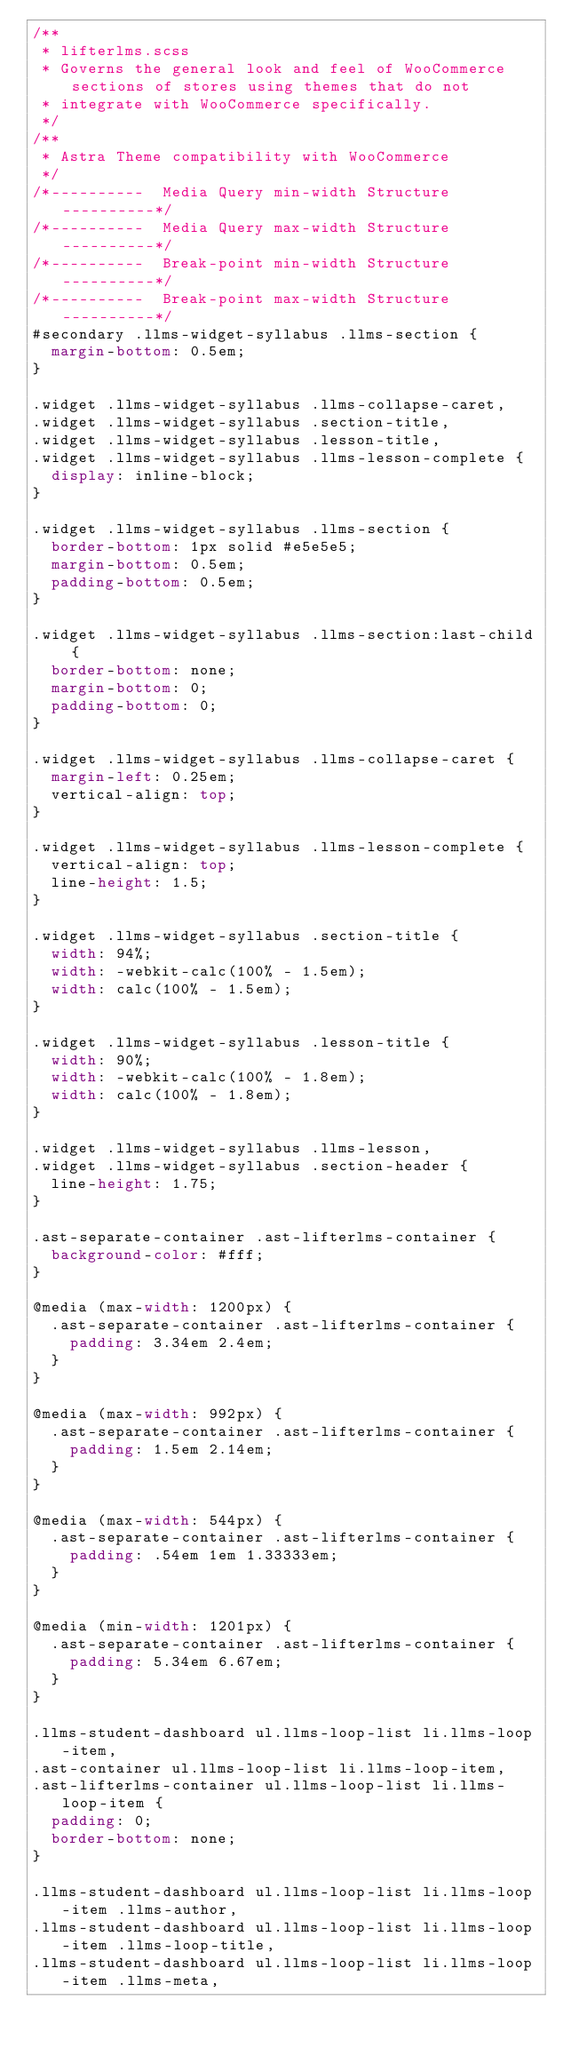Convert code to text. <code><loc_0><loc_0><loc_500><loc_500><_CSS_>/**
 * lifterlms.scss
 * Governs the general look and feel of WooCommerce sections of stores using themes that do not
 * integrate with WooCommerce specifically.
 */
/**
 * Astra Theme compatibility with WooCommerce
 */
/*----------  Media Query min-width Structure   ----------*/
/*----------  Media Query max-width Structure   ----------*/
/*----------  Break-point min-width Structure   ----------*/
/*----------  Break-point max-width Structure   ----------*/
#secondary .llms-widget-syllabus .llms-section {
  margin-bottom: 0.5em;
}

.widget .llms-widget-syllabus .llms-collapse-caret,
.widget .llms-widget-syllabus .section-title,
.widget .llms-widget-syllabus .lesson-title,
.widget .llms-widget-syllabus .llms-lesson-complete {
  display: inline-block;
}

.widget .llms-widget-syllabus .llms-section {
  border-bottom: 1px solid #e5e5e5;
  margin-bottom: 0.5em;
  padding-bottom: 0.5em;
}

.widget .llms-widget-syllabus .llms-section:last-child {
  border-bottom: none;
  margin-bottom: 0;
  padding-bottom: 0;
}

.widget .llms-widget-syllabus .llms-collapse-caret {
  margin-left: 0.25em;
  vertical-align: top;
}

.widget .llms-widget-syllabus .llms-lesson-complete {
  vertical-align: top;
  line-height: 1.5;
}

.widget .llms-widget-syllabus .section-title {
  width: 94%;
  width: -webkit-calc(100% - 1.5em);
  width: calc(100% - 1.5em);
}

.widget .llms-widget-syllabus .lesson-title {
  width: 90%;
  width: -webkit-calc(100% - 1.8em);
  width: calc(100% - 1.8em);
}

.widget .llms-widget-syllabus .llms-lesson,
.widget .llms-widget-syllabus .section-header {
  line-height: 1.75;
}

.ast-separate-container .ast-lifterlms-container {
  background-color: #fff;
}

@media (max-width: 1200px) {
  .ast-separate-container .ast-lifterlms-container {
    padding: 3.34em 2.4em;
  }
}

@media (max-width: 992px) {
  .ast-separate-container .ast-lifterlms-container {
    padding: 1.5em 2.14em;
  }
}

@media (max-width: 544px) {
  .ast-separate-container .ast-lifterlms-container {
    padding: .54em 1em 1.33333em;
  }
}

@media (min-width: 1201px) {
  .ast-separate-container .ast-lifterlms-container {
    padding: 5.34em 6.67em;
  }
}

.llms-student-dashboard ul.llms-loop-list li.llms-loop-item,
.ast-container ul.llms-loop-list li.llms-loop-item,
.ast-lifterlms-container ul.llms-loop-list li.llms-loop-item {
  padding: 0;
  border-bottom: none;
}

.llms-student-dashboard ul.llms-loop-list li.llms-loop-item .llms-author,
.llms-student-dashboard ul.llms-loop-list li.llms-loop-item .llms-loop-title,
.llms-student-dashboard ul.llms-loop-list li.llms-loop-item .llms-meta,</code> 